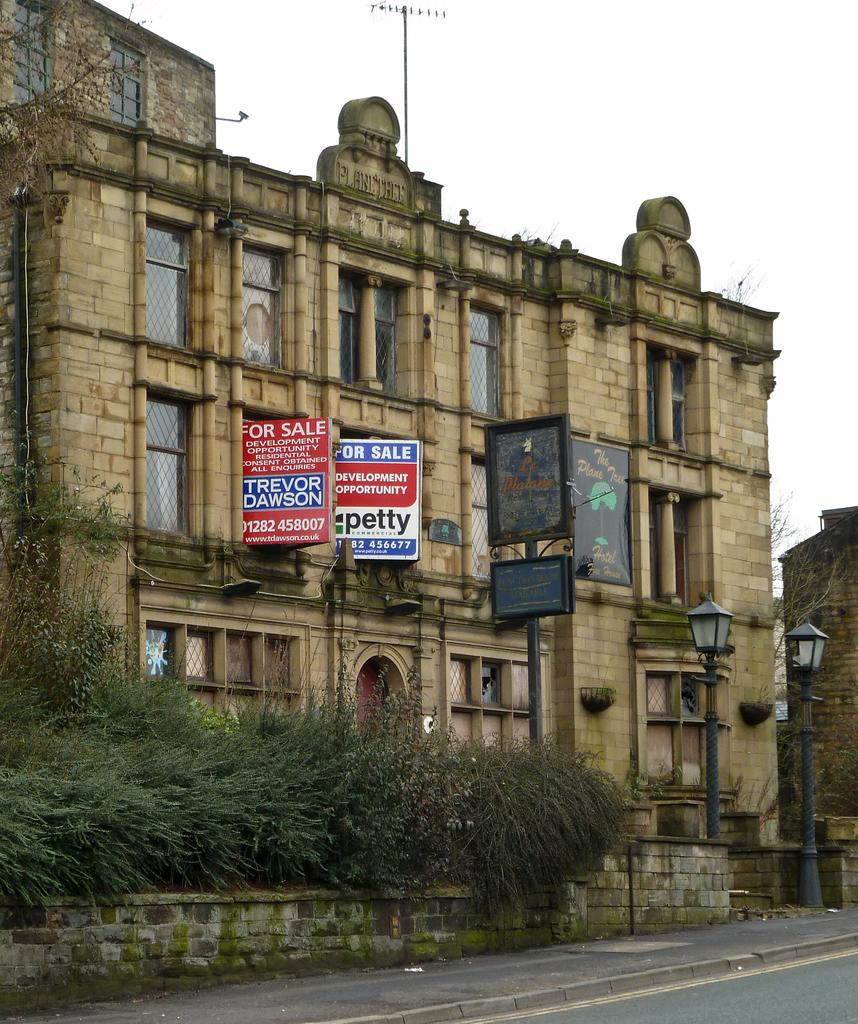What type of surface can be seen in the image? There is a road in the image. What type of natural elements are present in the image? There are plants in the image. What type of man-made structure is visible in the image? There is a wall in the image. What type of signage or information is present in the image? There are boards in the image. What type of lighting is present in the image? There are lights on poles in the image. What type of building is visible in the image? There is a building in the image. What type of openings are present in the building? There are windows in the building. What type of natural element is visible in the background of the image? The sky is visible in the image. Where is the kettle located in the image? There is no kettle present in the image. What type of test is being conducted in the image? There is no test being conducted in the image. What type of drum is visible in the image? There is no drum present in the image. 